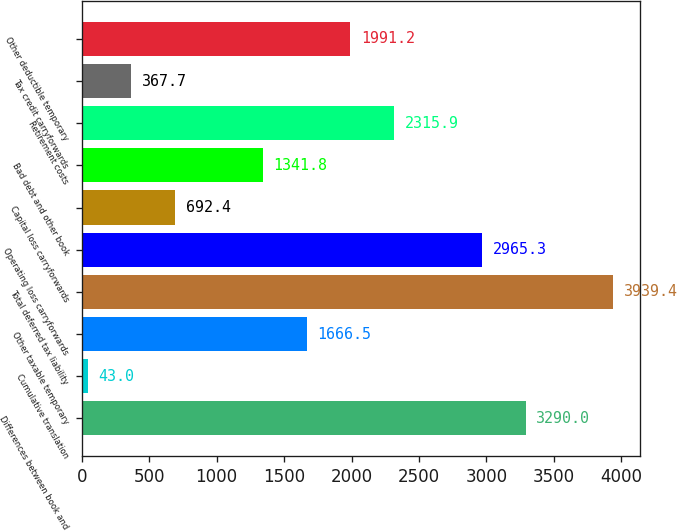Convert chart to OTSL. <chart><loc_0><loc_0><loc_500><loc_500><bar_chart><fcel>Differences between book and<fcel>Cumulative translation<fcel>Other taxable temporary<fcel>Total deferred tax liability<fcel>Operating loss carryforwards<fcel>Capital loss carryforwards<fcel>Bad debt and other book<fcel>Retirement costs<fcel>Tax credit carryforwards<fcel>Other deductible temporary<nl><fcel>3290<fcel>43<fcel>1666.5<fcel>3939.4<fcel>2965.3<fcel>692.4<fcel>1341.8<fcel>2315.9<fcel>367.7<fcel>1991.2<nl></chart> 